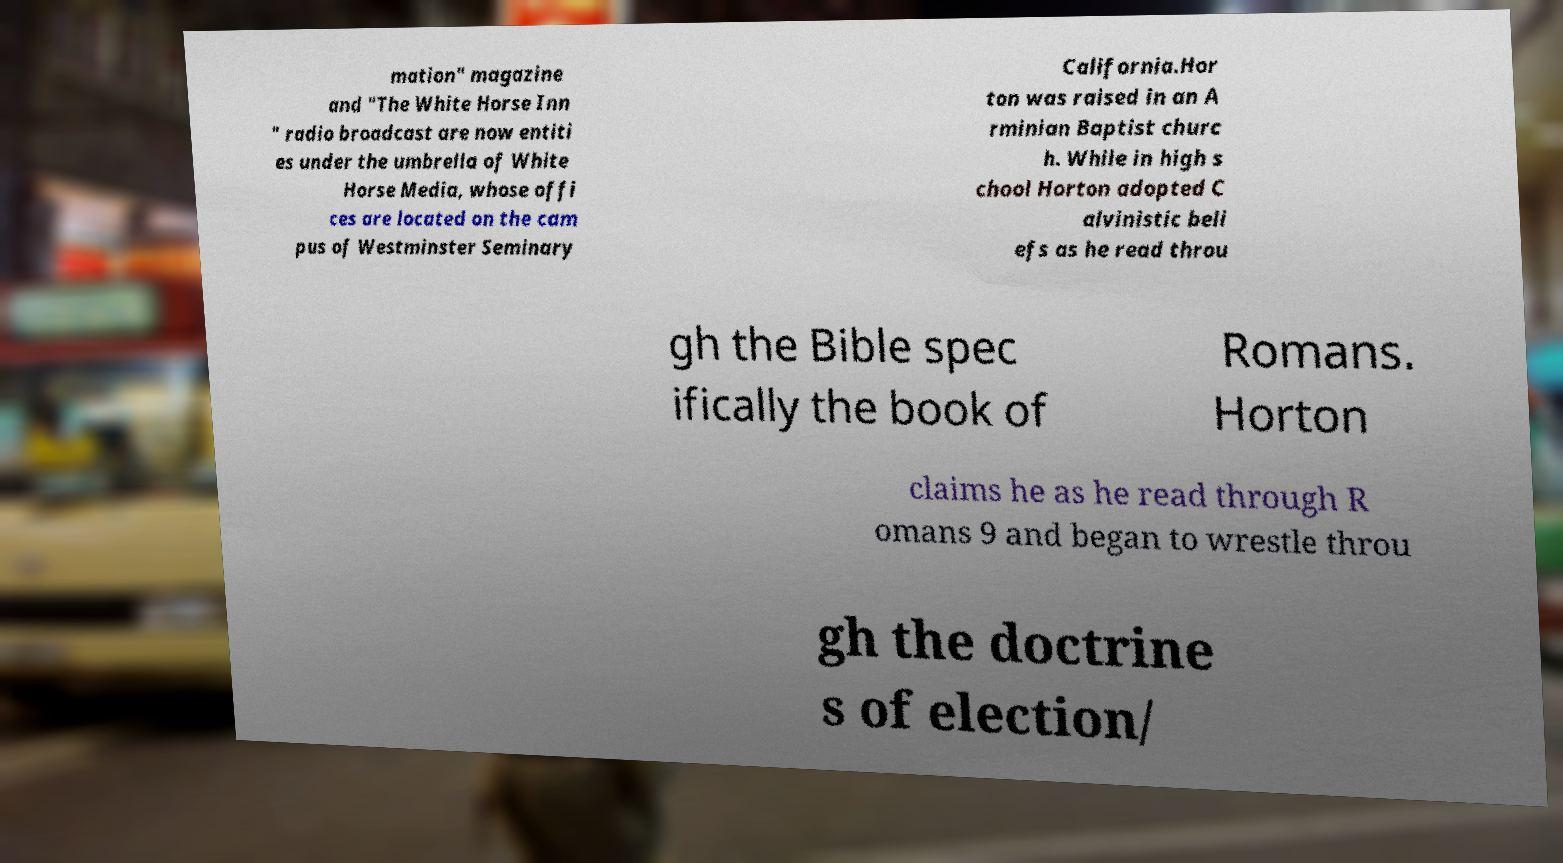Can you read and provide the text displayed in the image?This photo seems to have some interesting text. Can you extract and type it out for me? mation" magazine and "The White Horse Inn " radio broadcast are now entiti es under the umbrella of White Horse Media, whose offi ces are located on the cam pus of Westminster Seminary California.Hor ton was raised in an A rminian Baptist churc h. While in high s chool Horton adopted C alvinistic beli efs as he read throu gh the Bible spec ifically the book of Romans. Horton claims he as he read through R omans 9 and began to wrestle throu gh the doctrine s of election/ 